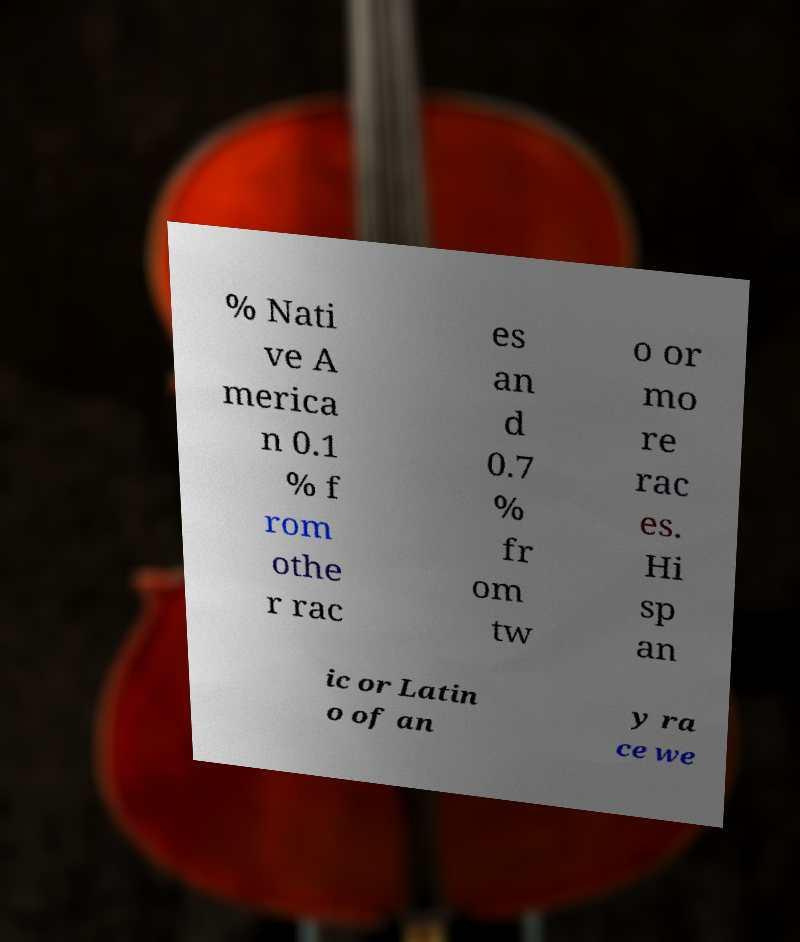Can you accurately transcribe the text from the provided image for me? % Nati ve A merica n 0.1 % f rom othe r rac es an d 0.7 % fr om tw o or mo re rac es. Hi sp an ic or Latin o of an y ra ce we 